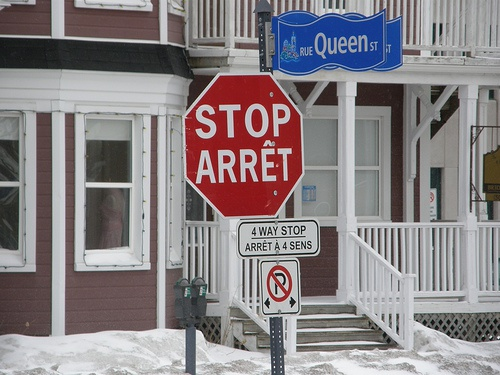Describe the objects in this image and their specific colors. I can see stop sign in darkgray, brown, and lightgray tones, parking meter in darkgray, gray, purple, and black tones, and parking meter in darkgray, gray, black, and purple tones in this image. 